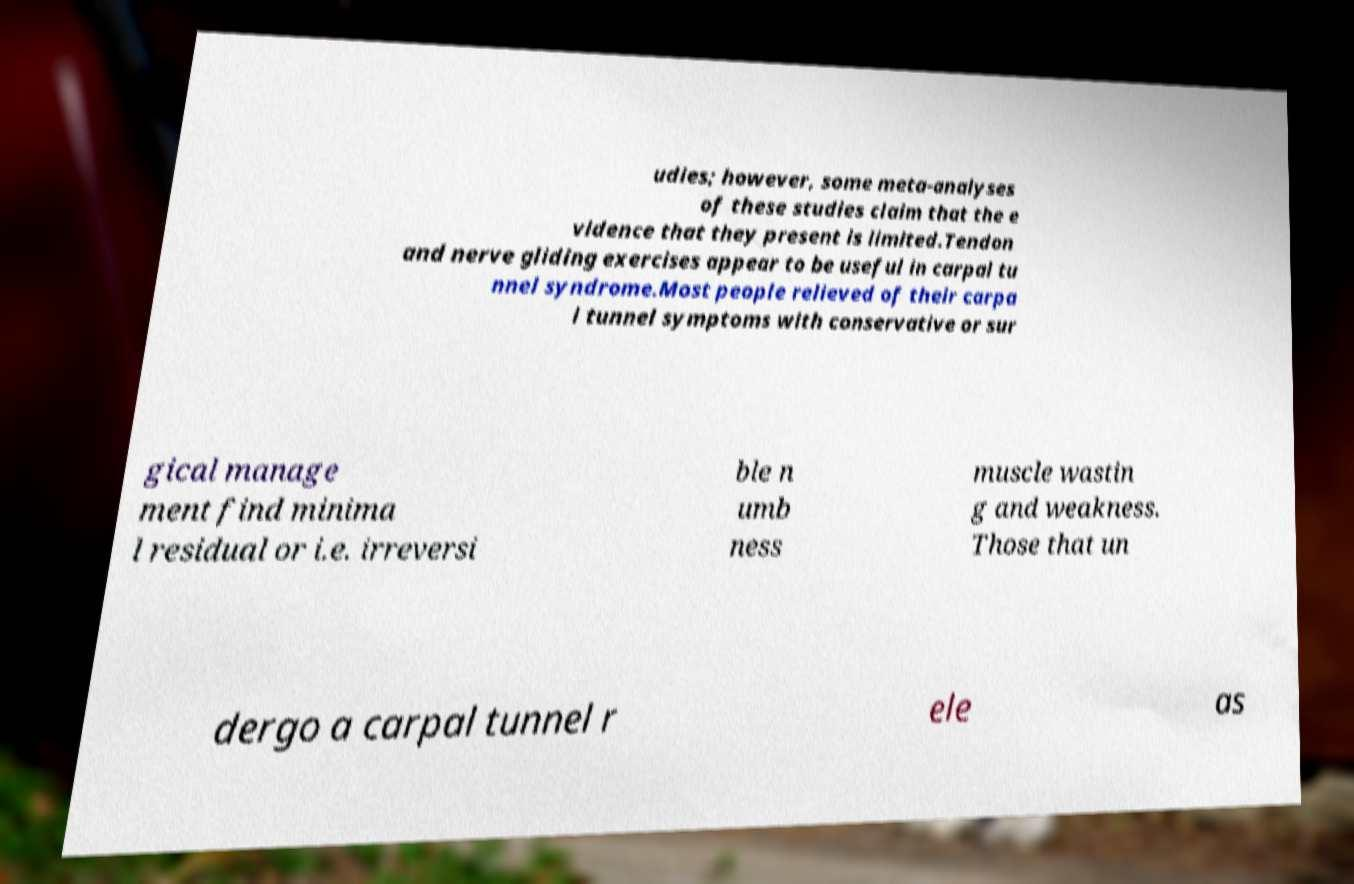Please read and relay the text visible in this image. What does it say? udies; however, some meta-analyses of these studies claim that the e vidence that they present is limited.Tendon and nerve gliding exercises appear to be useful in carpal tu nnel syndrome.Most people relieved of their carpa l tunnel symptoms with conservative or sur gical manage ment find minima l residual or i.e. irreversi ble n umb ness muscle wastin g and weakness. Those that un dergo a carpal tunnel r ele as 